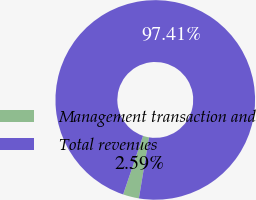<chart> <loc_0><loc_0><loc_500><loc_500><pie_chart><fcel>Management transaction and<fcel>Total revenues<nl><fcel>2.59%<fcel>97.41%<nl></chart> 